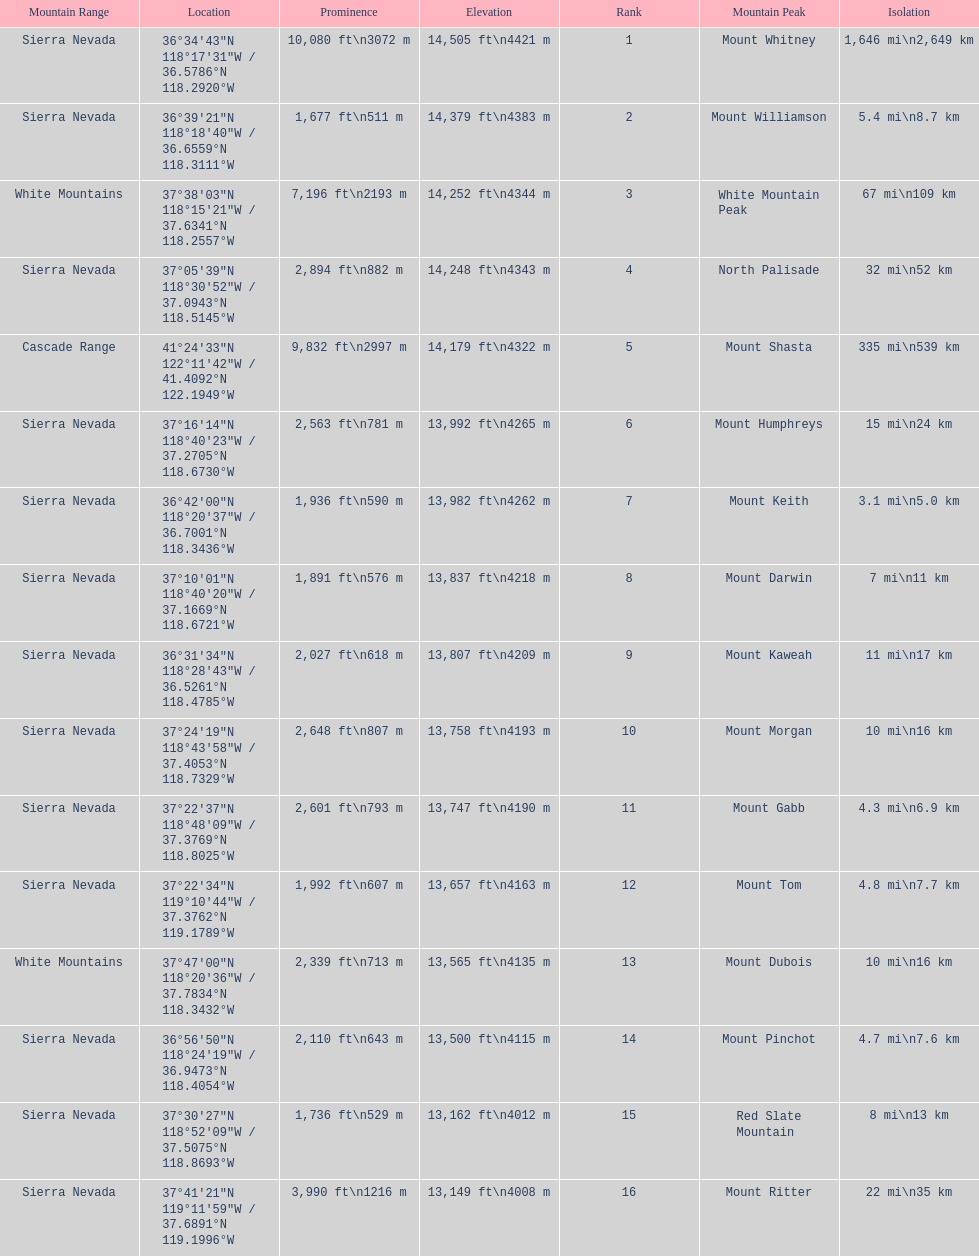In feet, what is the difference between the tallest peak and the 9th tallest peak in california? 698 ft. 